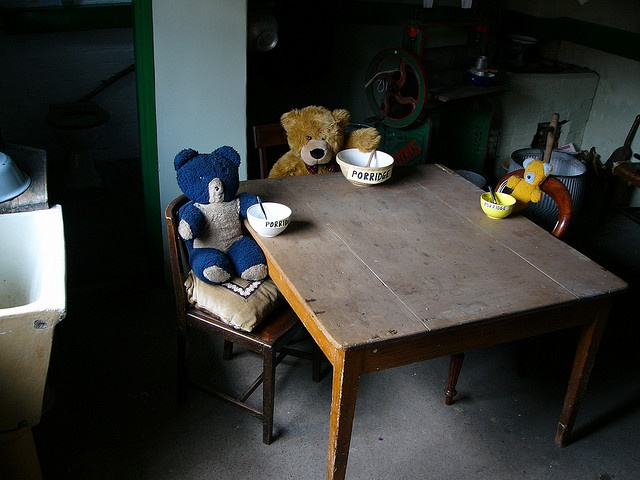Describe the objects in this image and their specific colors. I can see dining table in black and gray tones, chair in black, gray, maroon, and orange tones, teddy bear in black, navy, gray, and darkgray tones, sink in black, white, darkgray, lightblue, and gray tones, and teddy bear in black, olive, and tan tones in this image. 